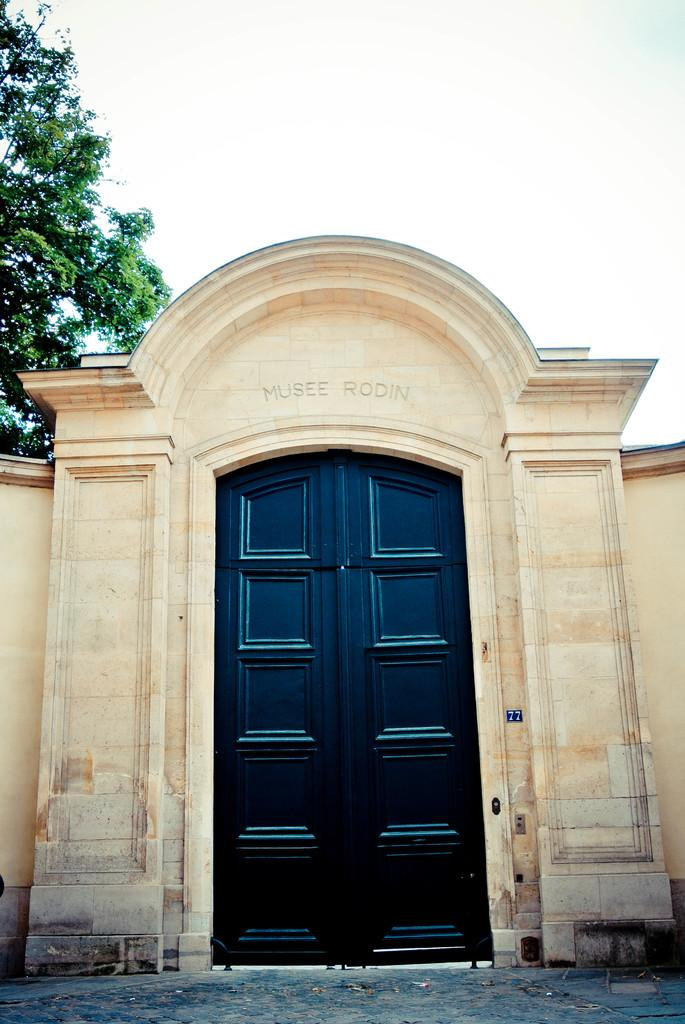What is the main subject in the middle of the image? There is a black door in the middle of the image. What can be seen on the left side of the image? There is a tree on the left side of the image. What is visible in the background of the image? The background of the image is the sky. What is the texture of the friend's thumb in the image? There is no friend or thumb present in the image. 